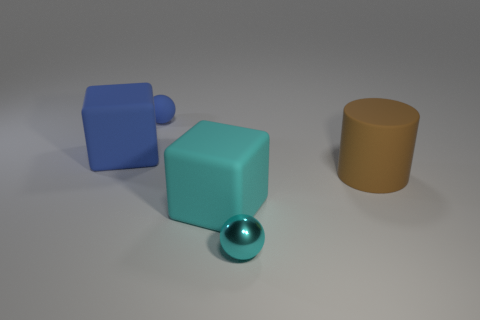Add 1 spheres. How many objects exist? 6 Subtract all cylinders. How many objects are left? 4 Subtract all big red rubber things. Subtract all rubber cylinders. How many objects are left? 4 Add 5 large cylinders. How many large cylinders are left? 6 Add 3 blue spheres. How many blue spheres exist? 4 Subtract 0 yellow cubes. How many objects are left? 5 